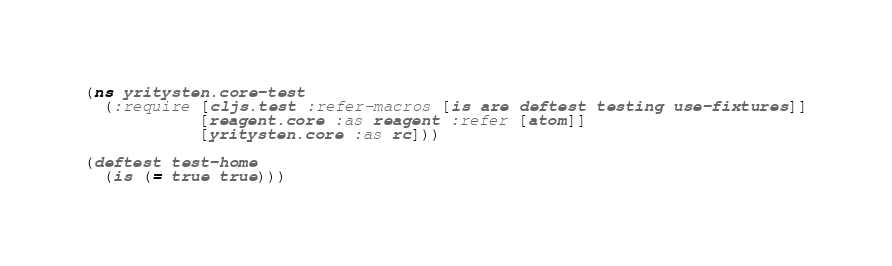<code> <loc_0><loc_0><loc_500><loc_500><_Clojure_>(ns yritysten.core-test
  (:require [cljs.test :refer-macros [is are deftest testing use-fixtures]]
            [reagent.core :as reagent :refer [atom]]
            [yritysten.core :as rc]))

(deftest test-home
  (is (= true true)))

</code> 